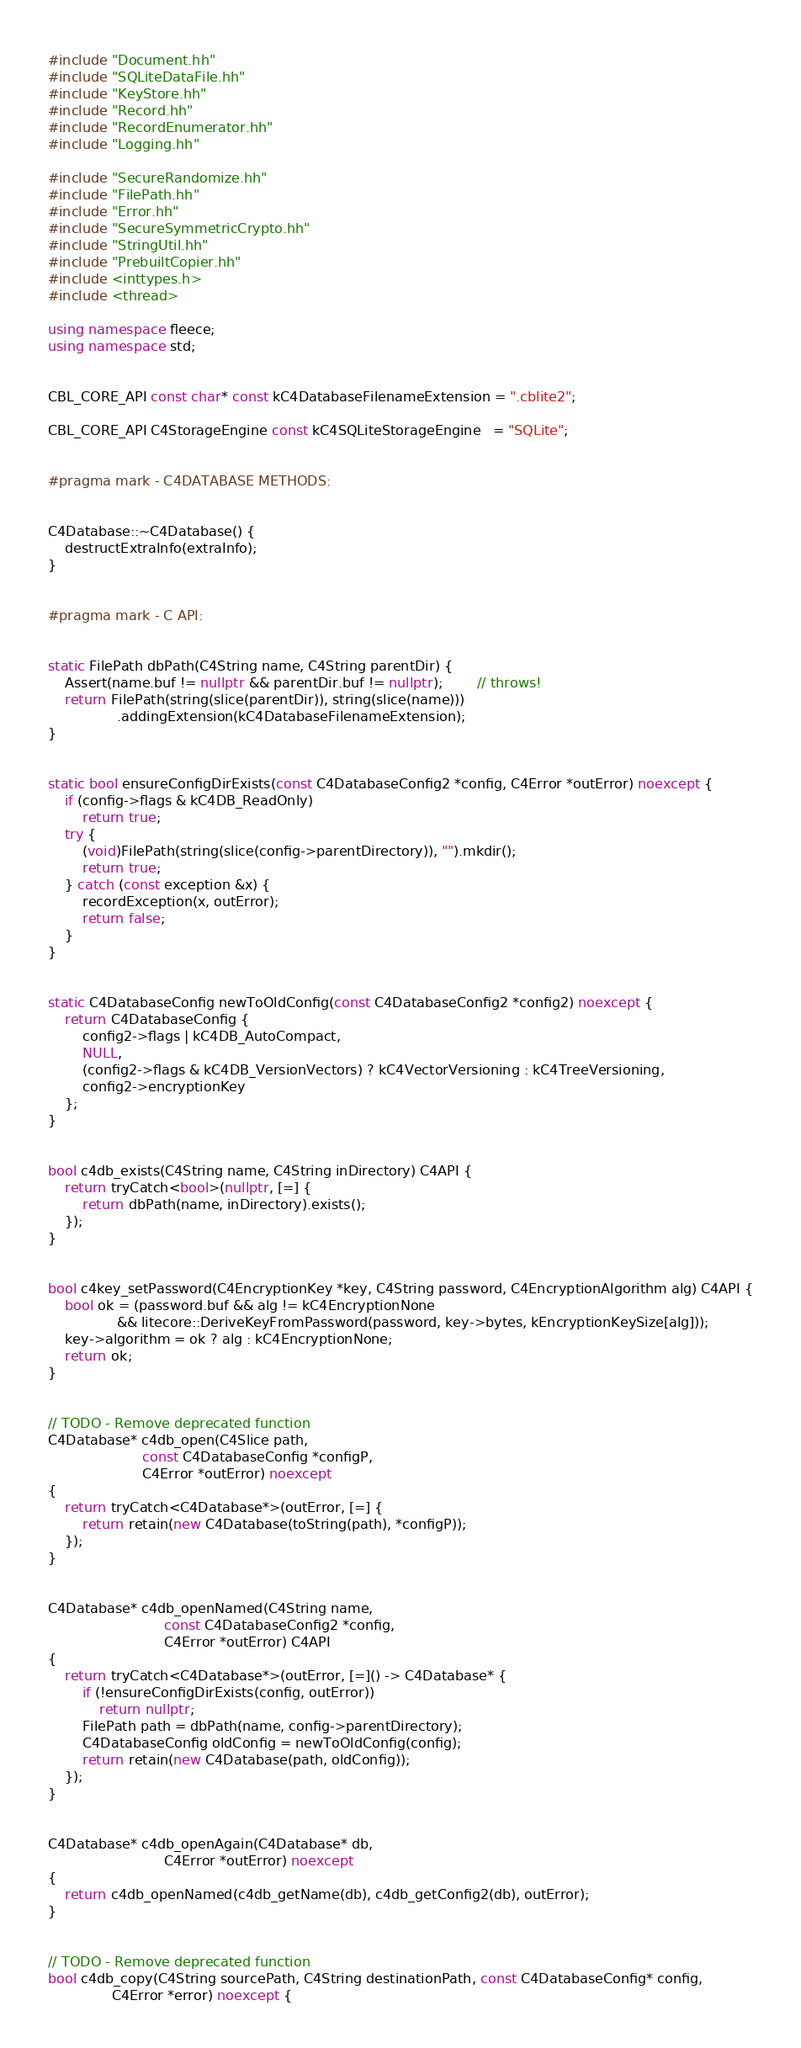Convert code to text. <code><loc_0><loc_0><loc_500><loc_500><_C++_>
#include "Document.hh"
#include "SQLiteDataFile.hh"
#include "KeyStore.hh"
#include "Record.hh"
#include "RecordEnumerator.hh"
#include "Logging.hh"

#include "SecureRandomize.hh"
#include "FilePath.hh"
#include "Error.hh"
#include "SecureSymmetricCrypto.hh"
#include "StringUtil.hh"
#include "PrebuiltCopier.hh"
#include <inttypes.h>
#include <thread>

using namespace fleece;
using namespace std;


CBL_CORE_API const char* const kC4DatabaseFilenameExtension = ".cblite2";

CBL_CORE_API C4StorageEngine const kC4SQLiteStorageEngine   = "SQLite";


#pragma mark - C4DATABASE METHODS:


C4Database::~C4Database() {
    destructExtraInfo(extraInfo);
}


#pragma mark - C API:


static FilePath dbPath(C4String name, C4String parentDir) {
    Assert(name.buf != nullptr && parentDir.buf != nullptr);        // throws!
    return FilePath(string(slice(parentDir)), string(slice(name)))
                .addingExtension(kC4DatabaseFilenameExtension);
}


static bool ensureConfigDirExists(const C4DatabaseConfig2 *config, C4Error *outError) noexcept {
    if (config->flags & kC4DB_ReadOnly)
        return true;
    try {
        (void)FilePath(string(slice(config->parentDirectory)), "").mkdir();
        return true;
    } catch (const exception &x) {
        recordException(x, outError);
        return false;
    }
}


static C4DatabaseConfig newToOldConfig(const C4DatabaseConfig2 *config2) noexcept {
    return C4DatabaseConfig {
        config2->flags | kC4DB_AutoCompact,
        NULL,
        (config2->flags & kC4DB_VersionVectors) ? kC4VectorVersioning : kC4TreeVersioning,
        config2->encryptionKey
    };
}


bool c4db_exists(C4String name, C4String inDirectory) C4API {
    return tryCatch<bool>(nullptr, [=] {
        return dbPath(name, inDirectory).exists();
    });
}


bool c4key_setPassword(C4EncryptionKey *key, C4String password, C4EncryptionAlgorithm alg) C4API {
    bool ok = (password.buf && alg != kC4EncryptionNone
                && litecore::DeriveKeyFromPassword(password, key->bytes, kEncryptionKeySize[alg]));
    key->algorithm = ok ? alg : kC4EncryptionNone;
    return ok;
}


// TODO - Remove deprecated function
C4Database* c4db_open(C4Slice path,
                      const C4DatabaseConfig *configP,
                      C4Error *outError) noexcept
{
    return tryCatch<C4Database*>(outError, [=] {
        return retain(new C4Database(toString(path), *configP));
    });
}


C4Database* c4db_openNamed(C4String name,
                           const C4DatabaseConfig2 *config,
                           C4Error *outError) C4API
{
    return tryCatch<C4Database*>(outError, [=]() -> C4Database* {
        if (!ensureConfigDirExists(config, outError))
            return nullptr;
        FilePath path = dbPath(name, config->parentDirectory);
        C4DatabaseConfig oldConfig = newToOldConfig(config);
        return retain(new C4Database(path, oldConfig));
    });
}


C4Database* c4db_openAgain(C4Database* db,
                           C4Error *outError) noexcept
{
    return c4db_openNamed(c4db_getName(db), c4db_getConfig2(db), outError);
}


// TODO - Remove deprecated function
bool c4db_copy(C4String sourcePath, C4String destinationPath, const C4DatabaseConfig* config,
               C4Error *error) noexcept {</code> 